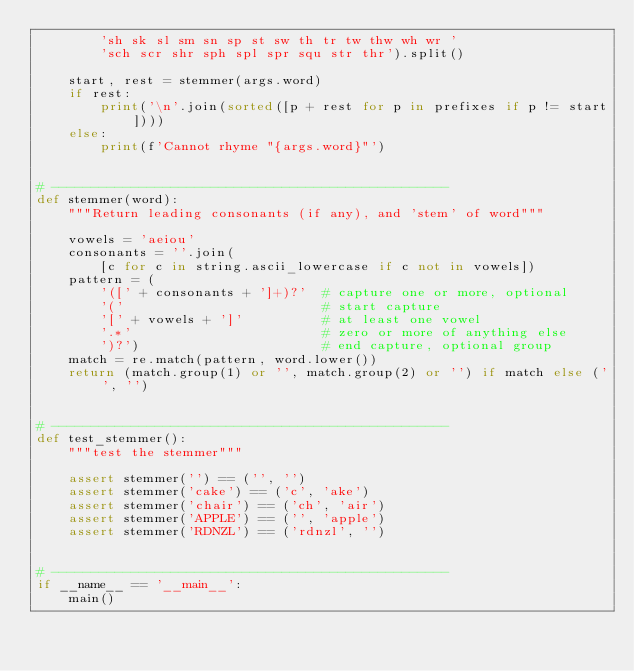<code> <loc_0><loc_0><loc_500><loc_500><_Python_>        'sh sk sl sm sn sp st sw th tr tw thw wh wr '
        'sch scr shr sph spl spr squ str thr').split()

    start, rest = stemmer(args.word)
    if rest:
        print('\n'.join(sorted([p + rest for p in prefixes if p != start])))
    else:
        print(f'Cannot rhyme "{args.word}"')


# --------------------------------------------------
def stemmer(word):
    """Return leading consonants (if any), and 'stem' of word"""

    vowels = 'aeiou'
    consonants = ''.join(
        [c for c in string.ascii_lowercase if c not in vowels])
    pattern = (
        '([' + consonants + ']+)?'  # capture one or more, optional
        '('                         # start capture
        '[' + vowels + ']'          # at least one vowel
        '.*'                        # zero or more of anything else
        ')?')                       # end capture, optional group
    match = re.match(pattern, word.lower())
    return (match.group(1) or '', match.group(2) or '') if match else ('', '')


# --------------------------------------------------
def test_stemmer():
    """test the stemmer"""

    assert stemmer('') == ('', '')
    assert stemmer('cake') == ('c', 'ake')
    assert stemmer('chair') == ('ch', 'air')
    assert stemmer('APPLE') == ('', 'apple')
    assert stemmer('RDNZL') == ('rdnzl', '')


# --------------------------------------------------
if __name__ == '__main__':
    main()
</code> 